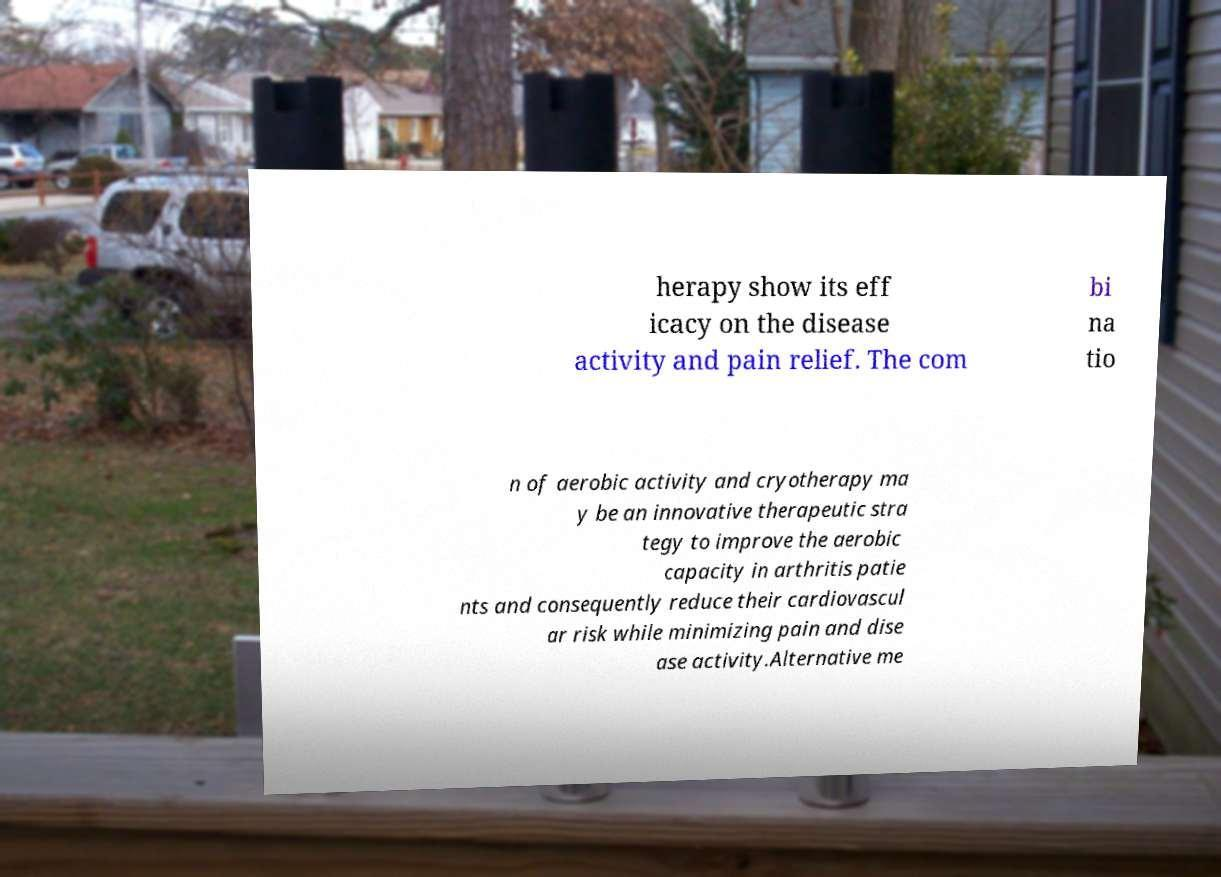I need the written content from this picture converted into text. Can you do that? herapy show its eff icacy on the disease activity and pain relief. The com bi na tio n of aerobic activity and cryotherapy ma y be an innovative therapeutic stra tegy to improve the aerobic capacity in arthritis patie nts and consequently reduce their cardiovascul ar risk while minimizing pain and dise ase activity.Alternative me 